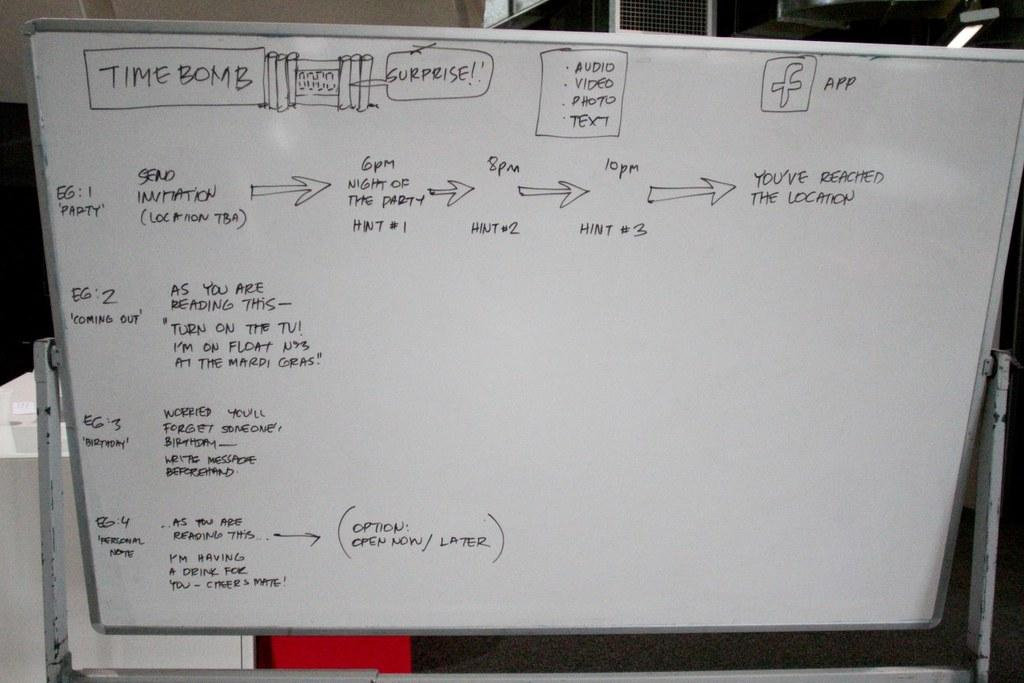Provide a one-sentence caption for the provided image. A white board has a box drawn at the top saying time bomb. 